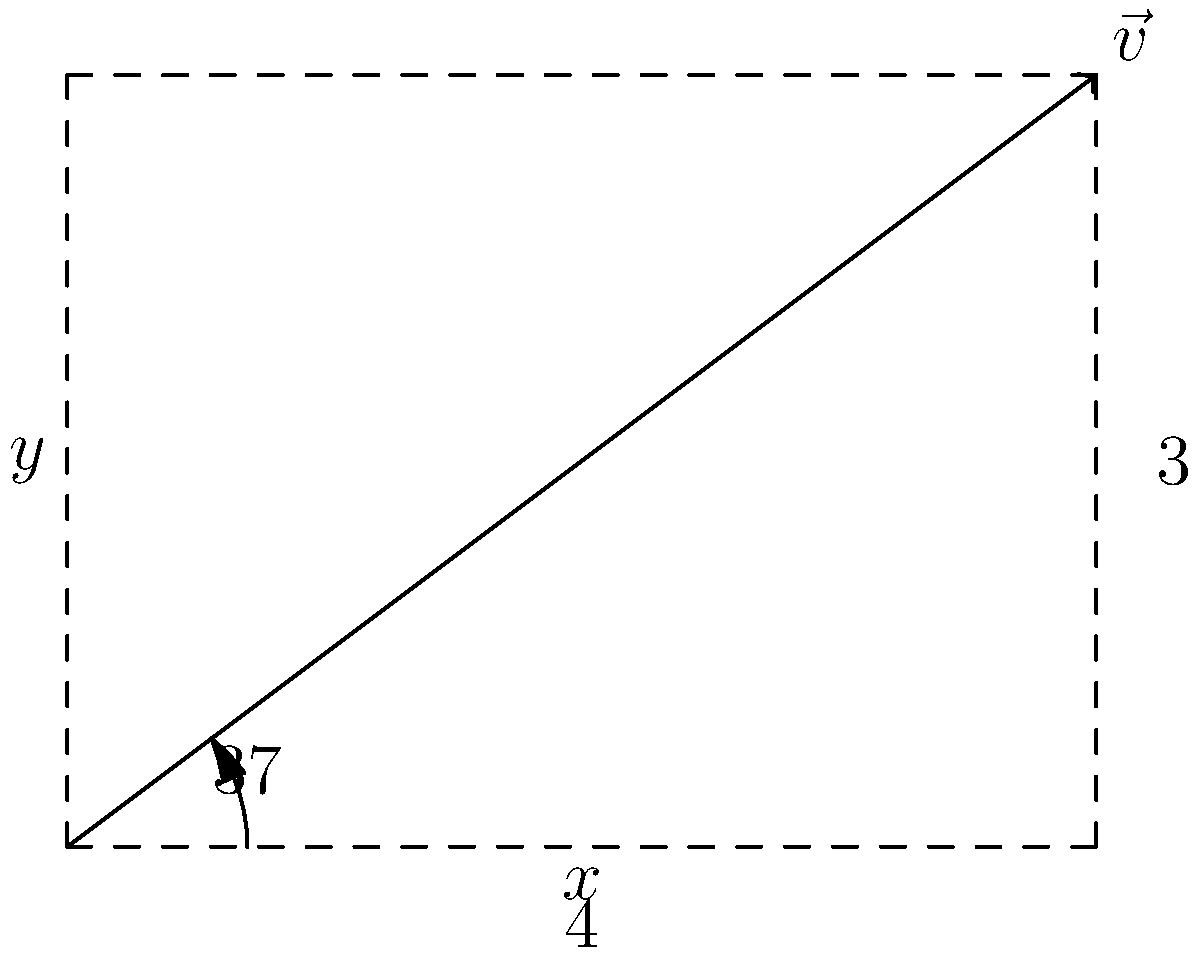Given the vector $\vec{v}$ shown in the diagram, with a magnitude of 5 units and an angle of 37° from the positive x-axis, determine its x and y components. How would you apply this decomposition in a software simulation of particle motion? To decompose the vector $\vec{v}$ into its x and y components, we'll use trigonometric functions. This process is crucial in software simulations for particle motion, as it allows us to track and update positions in a 2D space.

Step 1: Identify the given information
- Vector magnitude: 5 units
- Angle from positive x-axis: 37°

Step 2: Calculate the x-component
The x-component is the adjacent side of the right triangle formed by the vector and its projection on the x-axis.
$$x = |\vec{v}| \cos(\theta) = 5 \cos(37°) \approx 4$$

Step 3: Calculate the y-component
The y-component is the opposite side of the right triangle.
$$y = |\vec{v}| \sin(\theta) = 5 \sin(37°) \approx 3$$

Step 4: Express the vector in component form
$\vec{v} = (4, 3)$

In a software simulation of particle motion:
1. Store the x and y components separately.
2. Update each component independently based on forces or velocities in the simulation.
3. Use these components to calculate the new position of the particle in each time step.
4. If needed, recombine the components to find the new magnitude and direction of the vector.

This decomposition allows for more accurate and efficient calculations in simulations, as it simplifies the representation of motion in a 2D coordinate system.
Answer: $\vec{v} = (4, 3)$ 